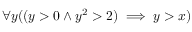<formula> <loc_0><loc_0><loc_500><loc_500>\forall y ( ( y > 0 \land y ^ { 2 } > 2 ) \implies y > x )</formula> 